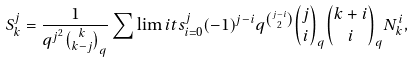<formula> <loc_0><loc_0><loc_500><loc_500>S _ { k } ^ { j } = \frac { 1 } { q ^ { j ^ { 2 } } { k \choose k - j } _ { q } } \sum \lim i t s _ { i = 0 } ^ { j } ( - 1 ) ^ { j - i } q ^ { j - i \choose 2 } { j \choose i } _ { q } { k + i \choose i } _ { q } N _ { k } ^ { i } ,</formula> 